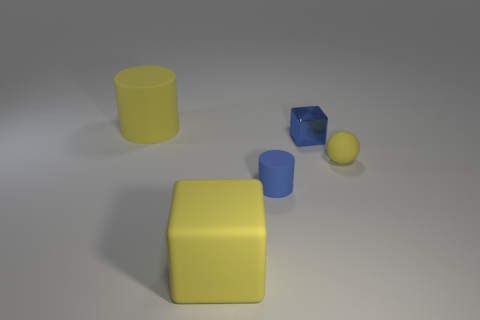Add 3 tiny blue metallic cubes. How many objects exist? 8 Subtract all balls. How many objects are left? 4 Add 1 large rubber cubes. How many large rubber cubes exist? 2 Subtract 1 blue blocks. How many objects are left? 4 Subtract all red rubber cubes. Subtract all tiny blue rubber cylinders. How many objects are left? 4 Add 3 tiny cylinders. How many tiny cylinders are left? 4 